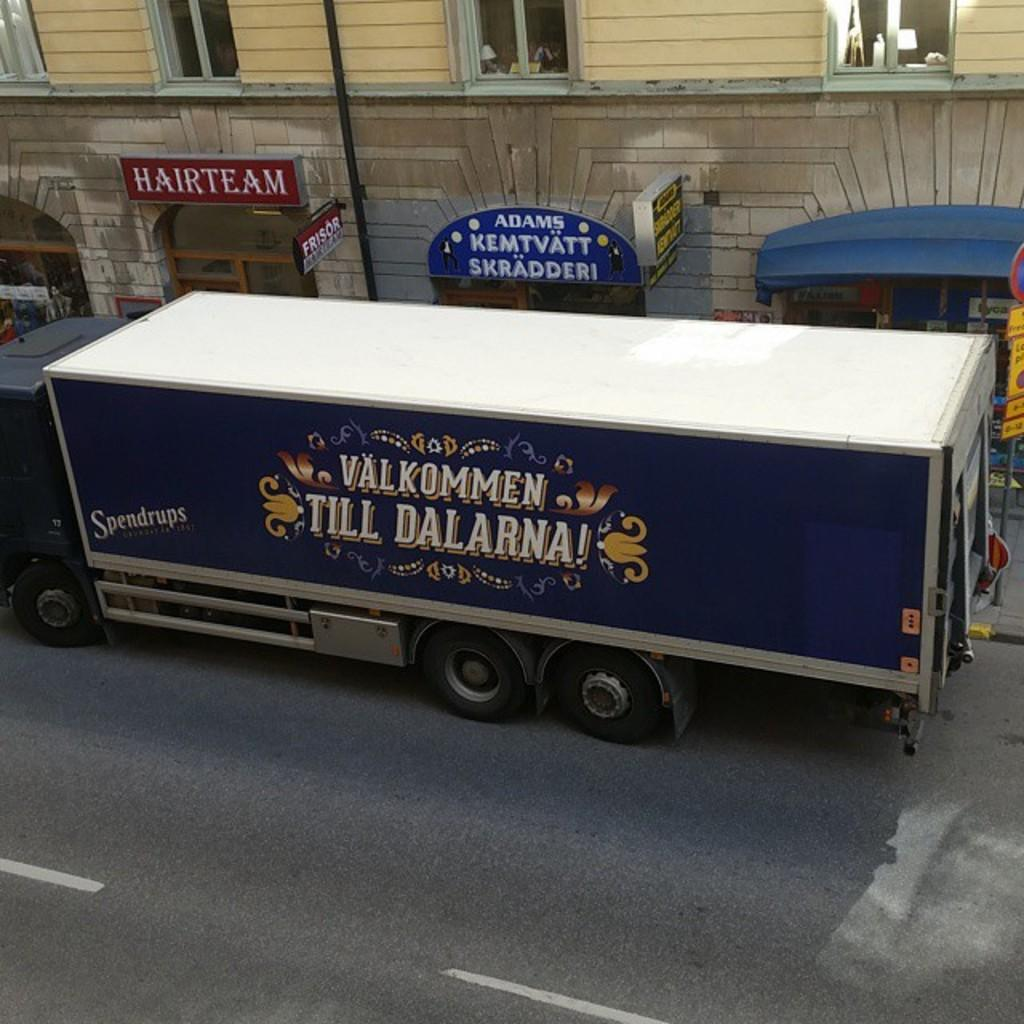What is the main subject of the image? The main subject of the image is a big truck. Where is the truck located in the image? The truck is on the road in the image. What can be seen on the side of the truck? There is text written on the side of the truck. What type of structures can be seen in the background of the image? There are stone walls, poles, windows, and signboards in the background of the image. What type of feast is being prepared on the boat in the image? There is no boat or feast present in the image; it features a big truck on the road with text on its side and various structures in the background. 